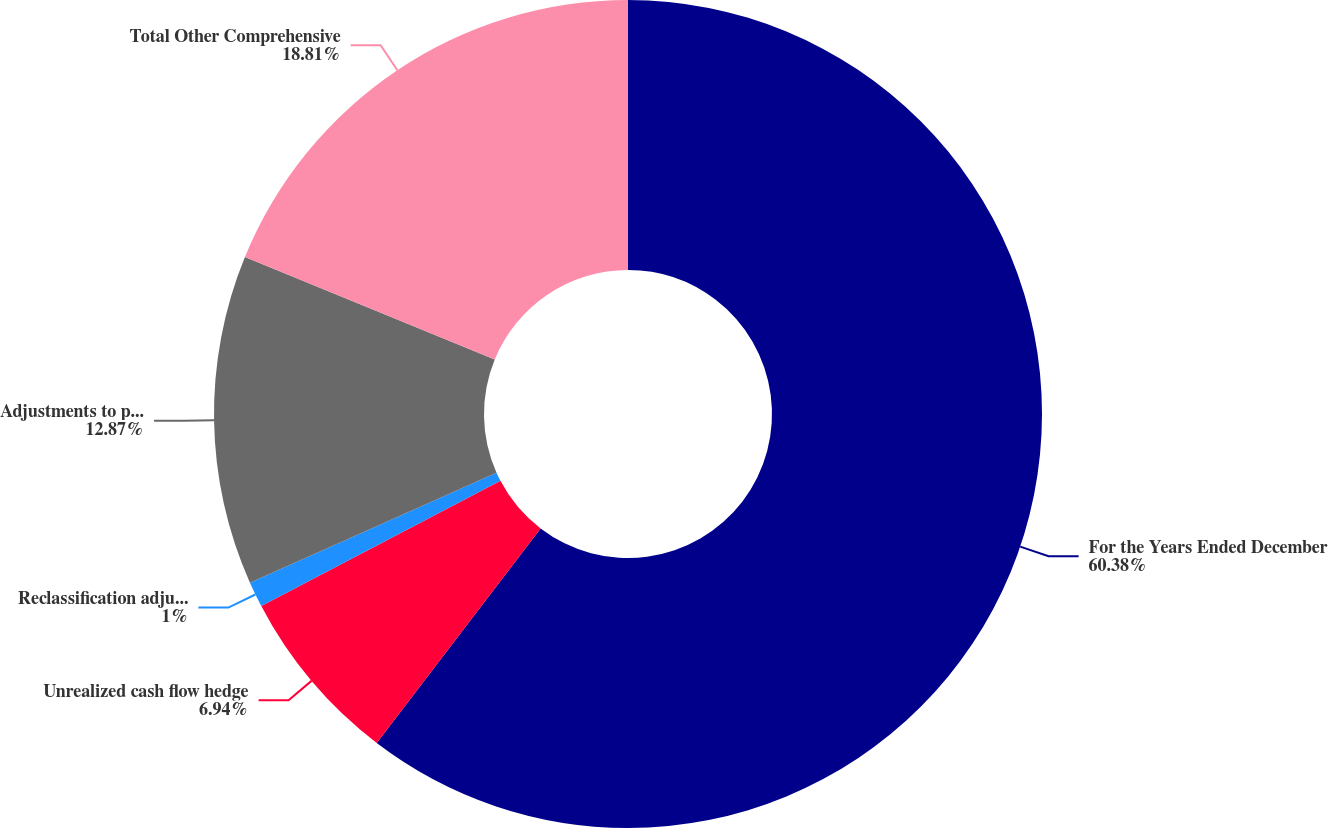Convert chart. <chart><loc_0><loc_0><loc_500><loc_500><pie_chart><fcel>For the Years Ended December<fcel>Unrealized cash flow hedge<fcel>Reclassification adjustments<fcel>Adjustments to prior service<fcel>Total Other Comprehensive<nl><fcel>60.38%<fcel>6.94%<fcel>1.0%<fcel>12.87%<fcel>18.81%<nl></chart> 